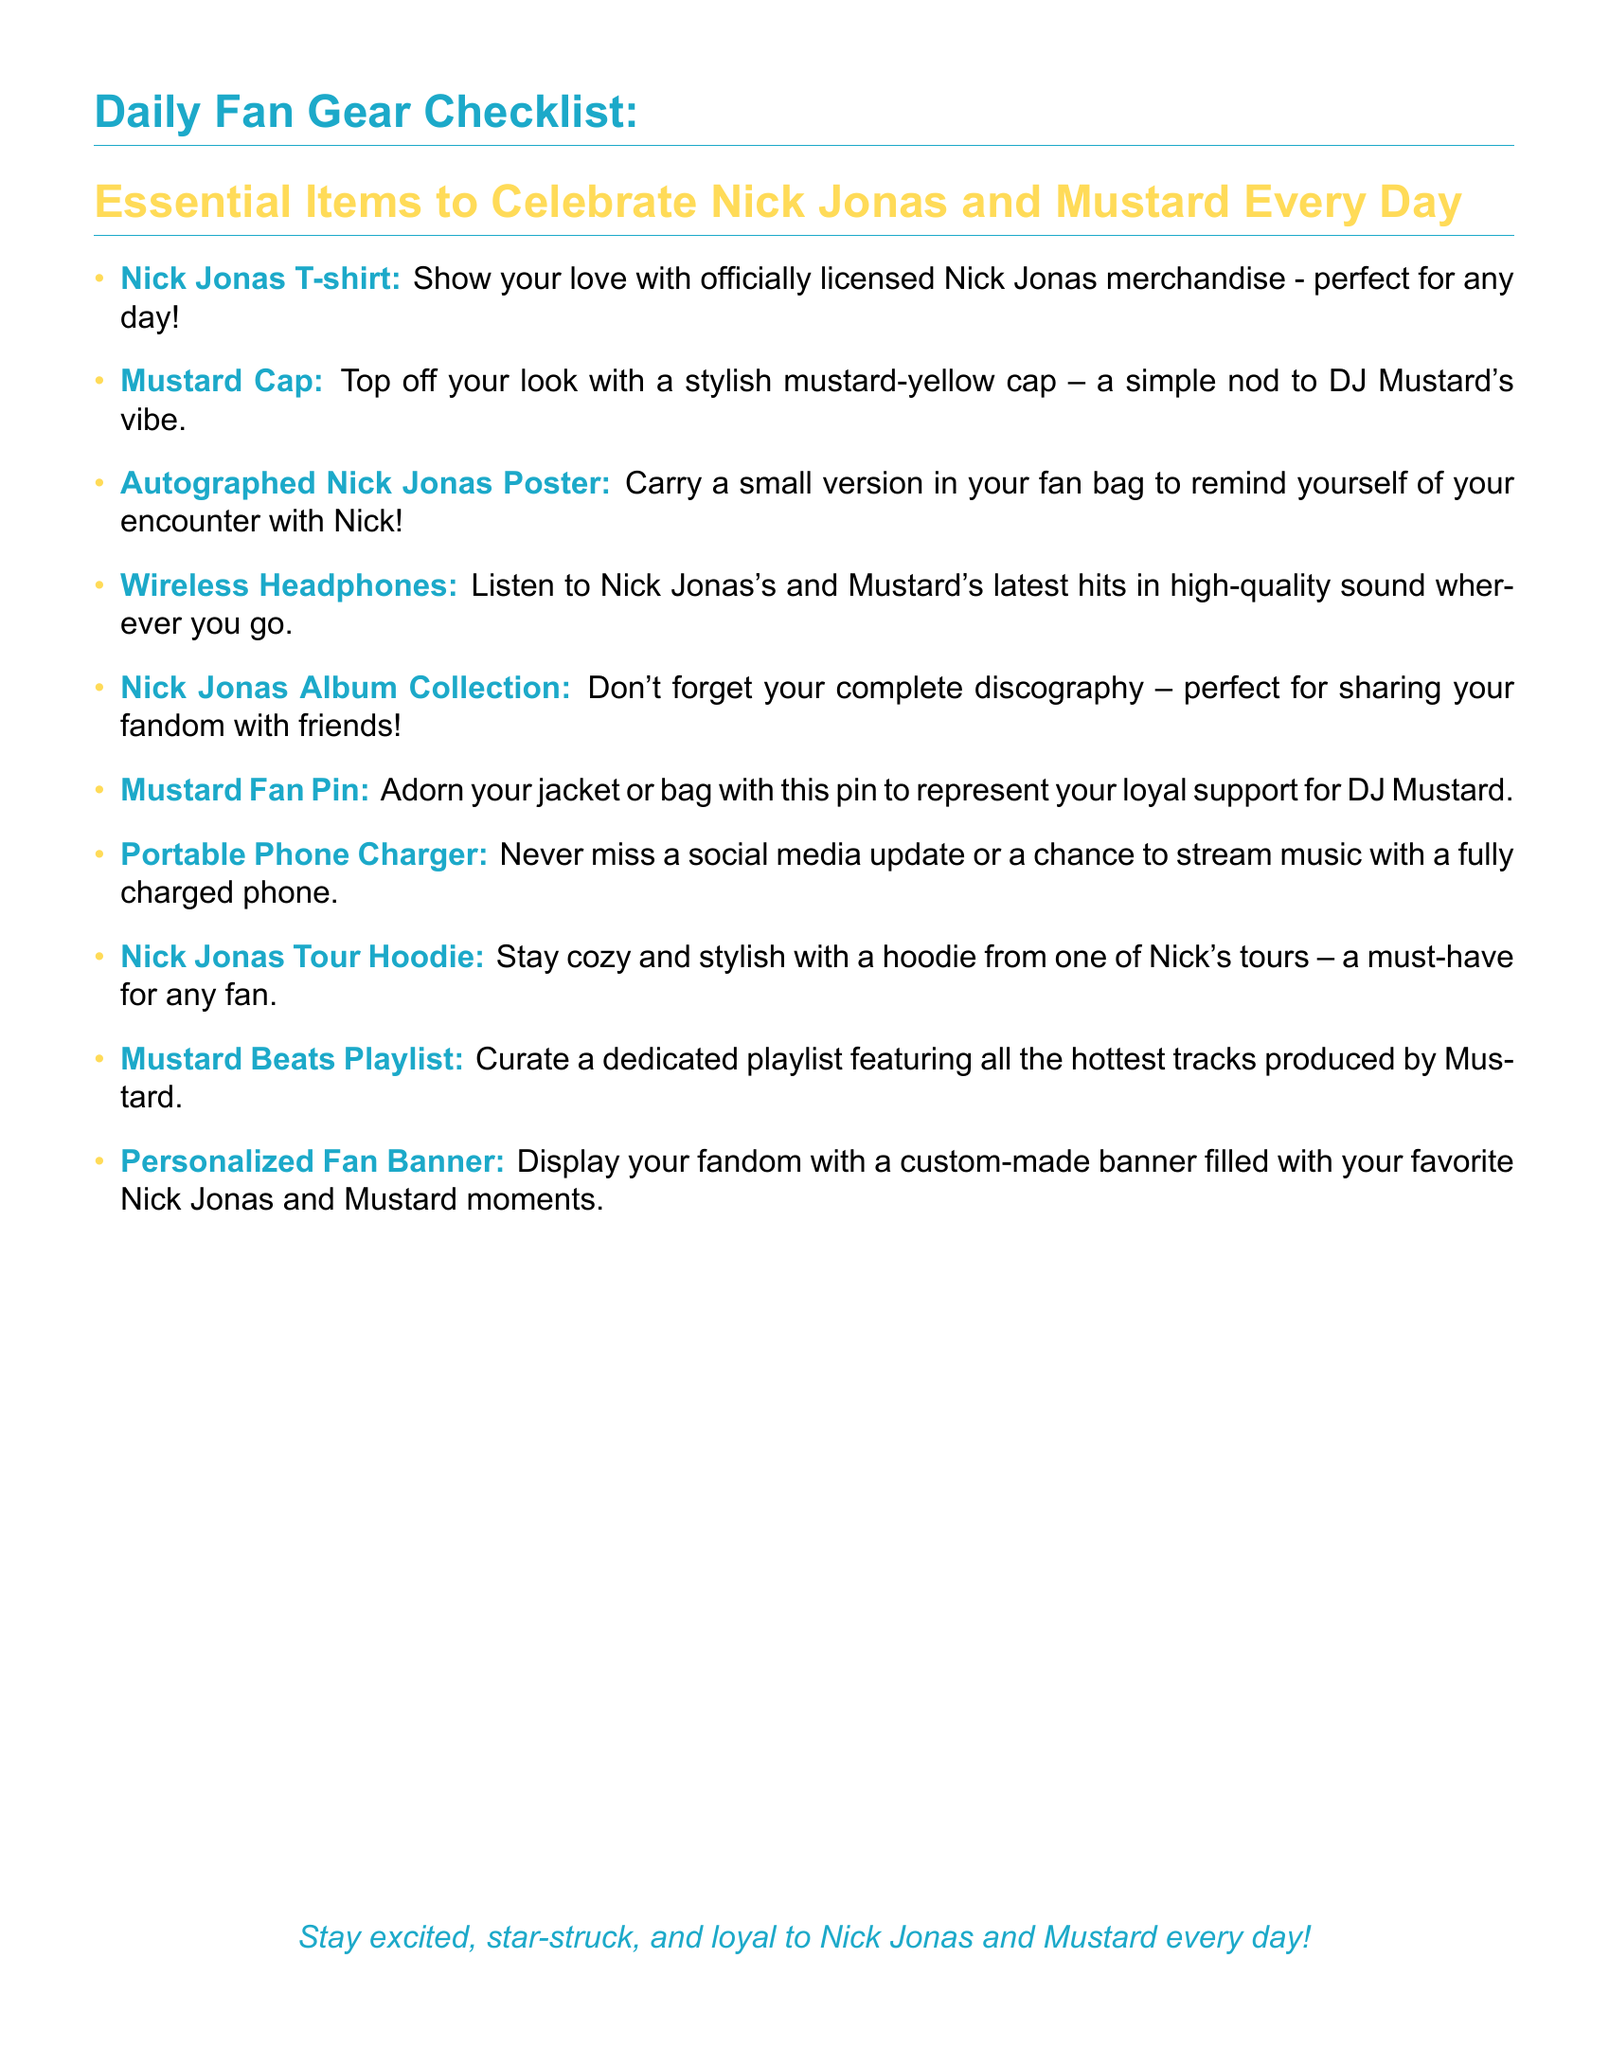What is the first item on the checklist? The first item listed in the document is a Nick Jonas T-shirt.
Answer: Nick Jonas T-shirt How many items are on the checklist? The checklist contains a total of 10 essential items.
Answer: 10 What color is the Mustard cap? The Mustard cap is described as mustard-yellow.
Answer: mustard-yellow What type of headphones are suggested? The document suggests using wireless headphones for listening to music.
Answer: Wireless Headphones What is the purpose of the Portable Phone Charger? The purpose of the Portable Phone Charger is to ensure a fully charged phone for social media updates and streaming music.
Answer: Never miss a social media update What should you carry to remind you of your encounter with Nick? You should carry an autographed Nick Jonas poster as a reminder.
Answer: Autographed Nick Jonas Poster What is a suggested item for listing Nick Jonas's music? The document suggests bringing a Nick Jonas album collection to share fandom with friends.
Answer: Nick Jonas Album Collection Which item represents DJ Mustard's vibe? The item that represents DJ Mustard's vibe is the Mustard cap.
Answer: Mustard Cap What type of playlist should you curate? You should curate a Mustard Beats playlist featuring the hottest tracks produced by Mustard.
Answer: Mustard Beats Playlist 